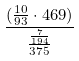Convert formula to latex. <formula><loc_0><loc_0><loc_500><loc_500>\frac { ( \frac { 1 0 } { 9 3 } \cdot 4 6 9 ) } { \frac { \frac { 7 } { 1 9 4 } } { 3 7 5 } }</formula> 